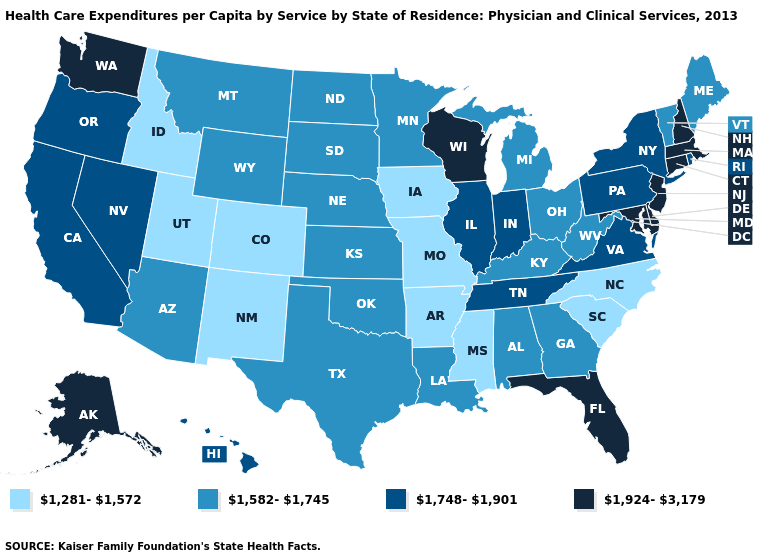Does the first symbol in the legend represent the smallest category?
Answer briefly. Yes. Does the map have missing data?
Keep it brief. No. What is the highest value in the USA?
Concise answer only. 1,924-3,179. Which states have the lowest value in the Northeast?
Write a very short answer. Maine, Vermont. Name the states that have a value in the range 1,582-1,745?
Quick response, please. Alabama, Arizona, Georgia, Kansas, Kentucky, Louisiana, Maine, Michigan, Minnesota, Montana, Nebraska, North Dakota, Ohio, Oklahoma, South Dakota, Texas, Vermont, West Virginia, Wyoming. How many symbols are there in the legend?
Answer briefly. 4. What is the highest value in the USA?
Give a very brief answer. 1,924-3,179. Among the states that border Alabama , which have the lowest value?
Keep it brief. Mississippi. What is the value of Washington?
Give a very brief answer. 1,924-3,179. What is the lowest value in the USA?
Answer briefly. 1,281-1,572. What is the lowest value in the USA?
Short answer required. 1,281-1,572. What is the value of Texas?
Concise answer only. 1,582-1,745. Is the legend a continuous bar?
Short answer required. No. Name the states that have a value in the range 1,281-1,572?
Concise answer only. Arkansas, Colorado, Idaho, Iowa, Mississippi, Missouri, New Mexico, North Carolina, South Carolina, Utah. What is the value of Pennsylvania?
Keep it brief. 1,748-1,901. 